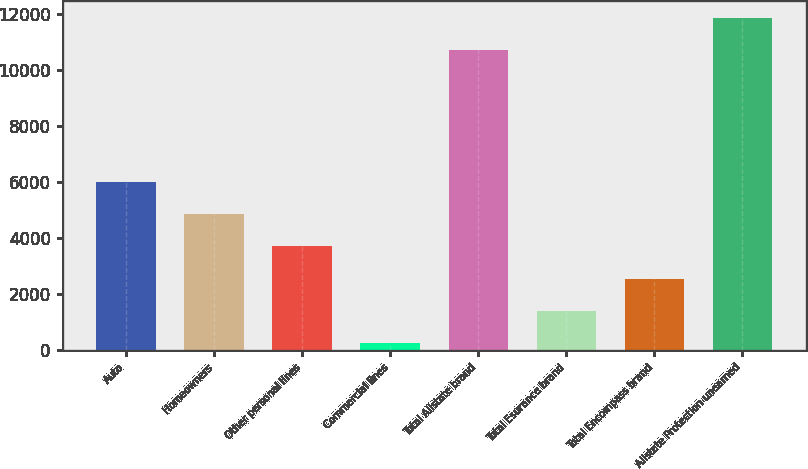Convert chart to OTSL. <chart><loc_0><loc_0><loc_500><loc_500><bar_chart><fcel>Auto<fcel>Homeowners<fcel>Other personal lines<fcel>Commercial lines<fcel>Total Allstate brand<fcel>Total Esurance brand<fcel>Total Encompass brand<fcel>Allstate Protection unearned<nl><fcel>6007.5<fcel>4856<fcel>3704.5<fcel>250<fcel>10710<fcel>1401.5<fcel>2553<fcel>11861.5<nl></chart> 